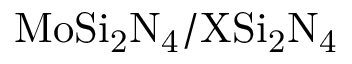Convert formula to latex. <formula><loc_0><loc_0><loc_500><loc_500>M o S i _ { 2 } N _ { 4 } / X S i _ { 2 } N _ { 4 }</formula> 